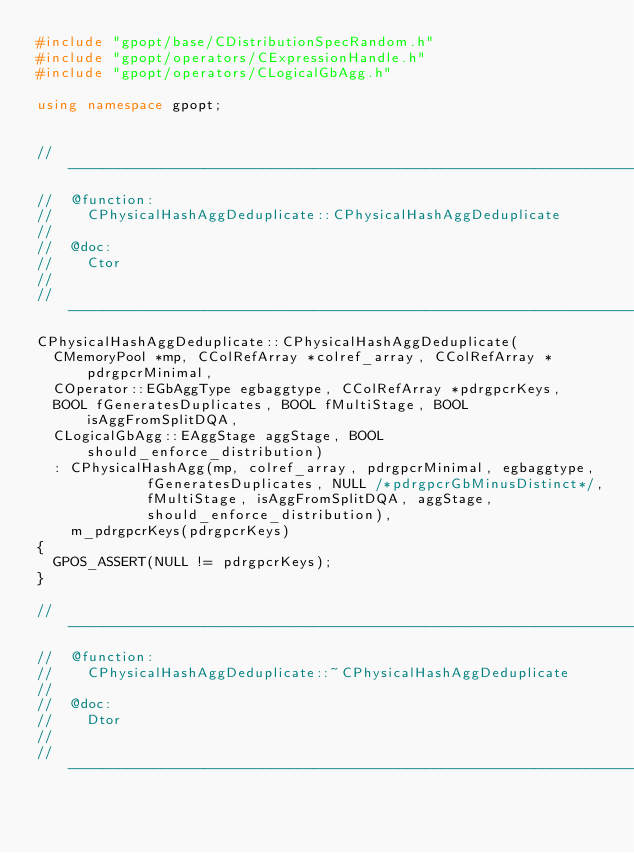Convert code to text. <code><loc_0><loc_0><loc_500><loc_500><_C++_>#include "gpopt/base/CDistributionSpecRandom.h"
#include "gpopt/operators/CExpressionHandle.h"
#include "gpopt/operators/CLogicalGbAgg.h"

using namespace gpopt;


//---------------------------------------------------------------------------
//	@function:
//		CPhysicalHashAggDeduplicate::CPhysicalHashAggDeduplicate
//
//	@doc:
//		Ctor
//
//---------------------------------------------------------------------------
CPhysicalHashAggDeduplicate::CPhysicalHashAggDeduplicate(
	CMemoryPool *mp, CColRefArray *colref_array, CColRefArray *pdrgpcrMinimal,
	COperator::EGbAggType egbaggtype, CColRefArray *pdrgpcrKeys,
	BOOL fGeneratesDuplicates, BOOL fMultiStage, BOOL isAggFromSplitDQA,
	CLogicalGbAgg::EAggStage aggStage, BOOL should_enforce_distribution)
	: CPhysicalHashAgg(mp, colref_array, pdrgpcrMinimal, egbaggtype,
					   fGeneratesDuplicates, NULL /*pdrgpcrGbMinusDistinct*/,
					   fMultiStage, isAggFromSplitDQA, aggStage,
					   should_enforce_distribution),
	  m_pdrgpcrKeys(pdrgpcrKeys)
{
	GPOS_ASSERT(NULL != pdrgpcrKeys);
}

//---------------------------------------------------------------------------
//	@function:
//		CPhysicalHashAggDeduplicate::~CPhysicalHashAggDeduplicate
//
//	@doc:
//		Dtor
//
//---------------------------------------------------------------------------</code> 